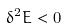<formula> <loc_0><loc_0><loc_500><loc_500>\delta ^ { 2 } E < 0</formula> 